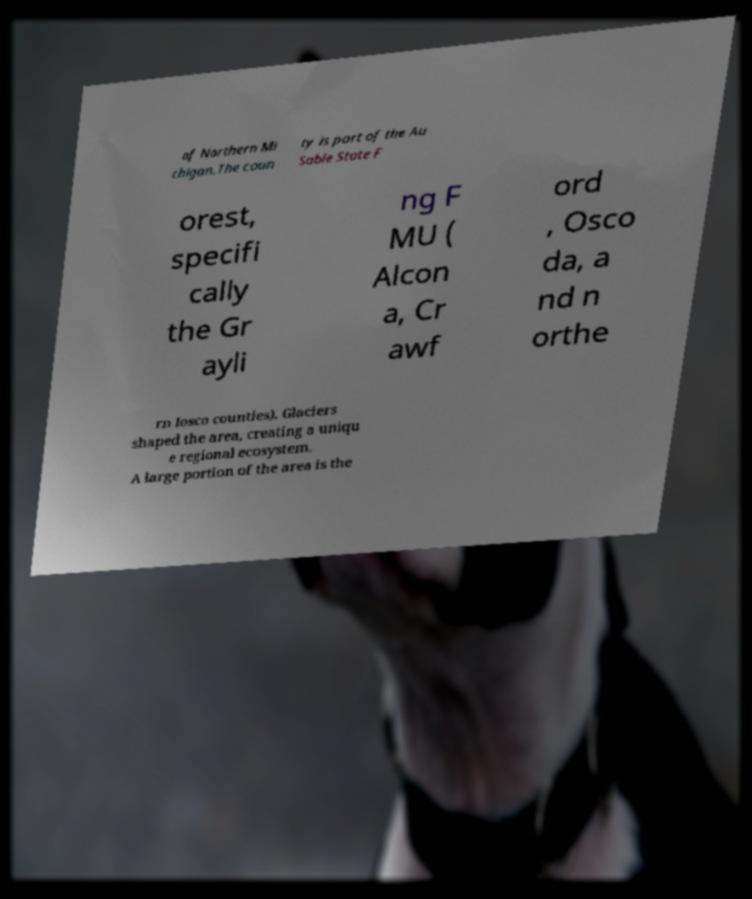Could you assist in decoding the text presented in this image and type it out clearly? of Northern Mi chigan.The coun ty is part of the Au Sable State F orest, specifi cally the Gr ayli ng F MU ( Alcon a, Cr awf ord , Osco da, a nd n orthe rn Iosco counties). Glaciers shaped the area, creating a uniqu e regional ecosystem. A large portion of the area is the 